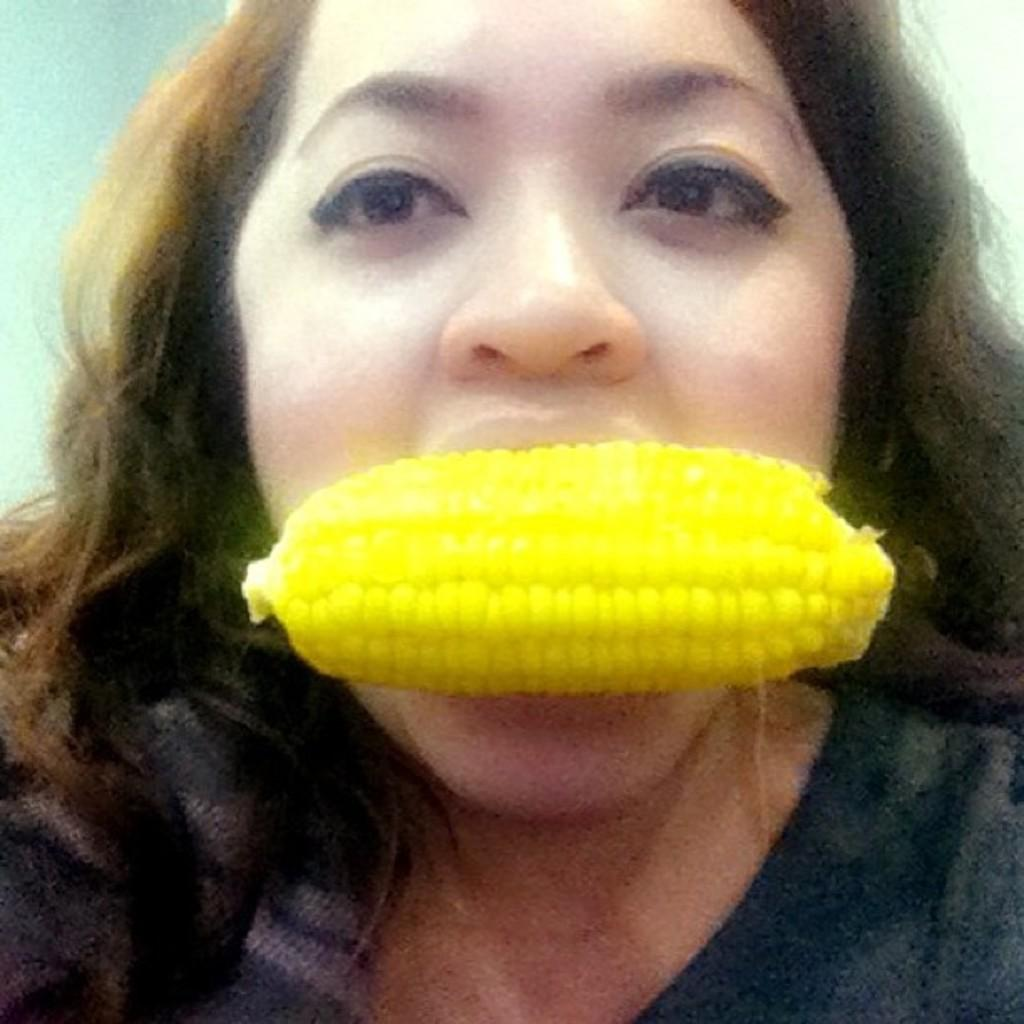Who is the main subject in the image? There is a lady in the image. What is the lady doing in the image? The lady has a corn in her mouth. What can be seen in the background of the image? There is a wall in the background of the image. What type of train can be seen passing by in the image? There is no train present in the image; it only features a lady with a corn in her mouth and a wall in the background. 